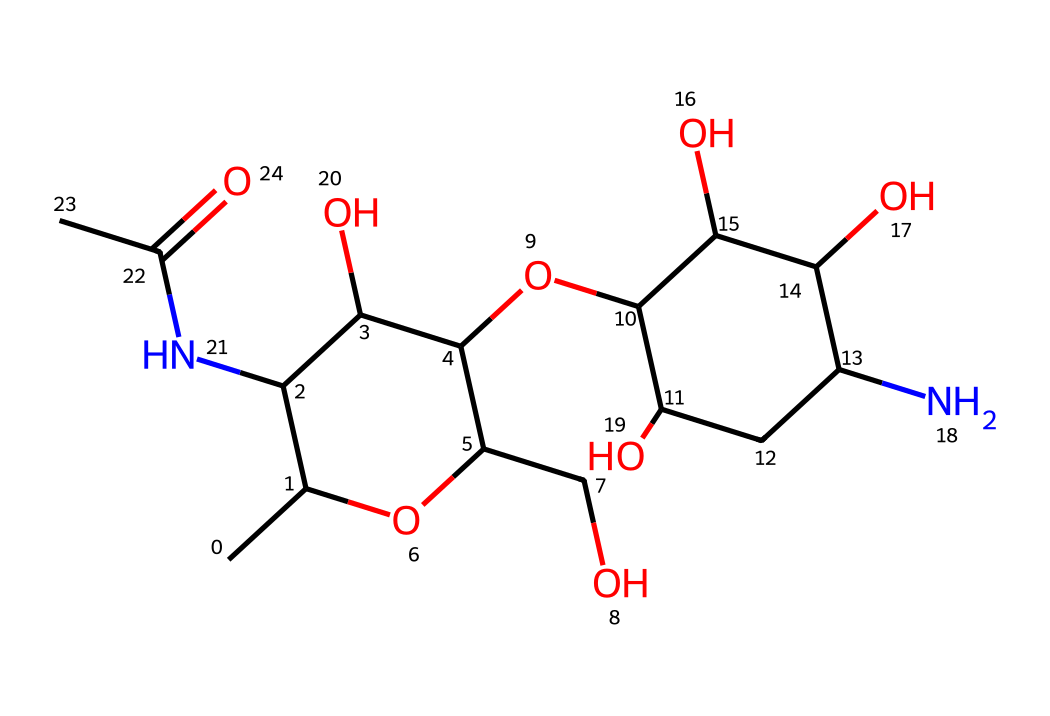What is the primary functional group present in chitosan? The primary functional group seen in the structure is the amine group (NH2), indicated by the nitrogen atom bonded to hydrogen atoms.
Answer: amine How many hydroxyl (-OH) groups are present in chitosan? Counting the –OH groups in the structure shows there are four hydroxyl groups, as evidenced by the oxygen atoms each bonded to hydrogen atoms.
Answer: four What type of intermolecular interactions are likely to occur due to the presence of amine and hydroxyl groups in chitosan? The presence of amine and hydroxyl groups suggests hydrogen bonding can occur between molecules, as these groups can both donate and accept hydrogen bonds.
Answer: hydrogen bonding What is the impact of the high content of hydroxyl groups on the solubility of chitosan? The high content of hydroxyl groups enhances the solubility of chitosan in water due to increased hydrogen bonding with water molecules.
Answer: increased solubility How many rings are present in the molecular structure of chitosan? The structure shows two distinct cyclic components, indicated by the presence of the two rings within the chemical diagram.
Answer: two What is the role of chitosan in tissue engineering due to its chemical structure? The chemical structure of chitosan, particularly its biodegradability and biocompatibility, plays a significant role in its application for scaffolds in tissue engineering.
Answer: scaffold material 